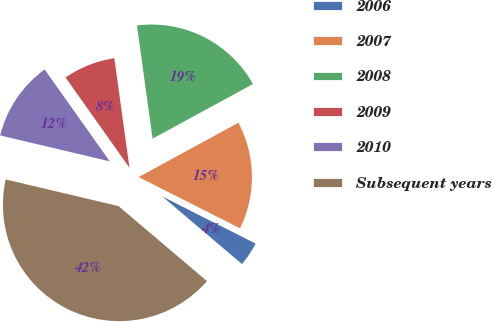<chart> <loc_0><loc_0><loc_500><loc_500><pie_chart><fcel>2006<fcel>2007<fcel>2008<fcel>2009<fcel>2010<fcel>Subsequent years<nl><fcel>3.75%<fcel>15.38%<fcel>19.25%<fcel>7.62%<fcel>11.5%<fcel>42.5%<nl></chart> 